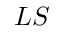<formula> <loc_0><loc_0><loc_500><loc_500>L S</formula> 